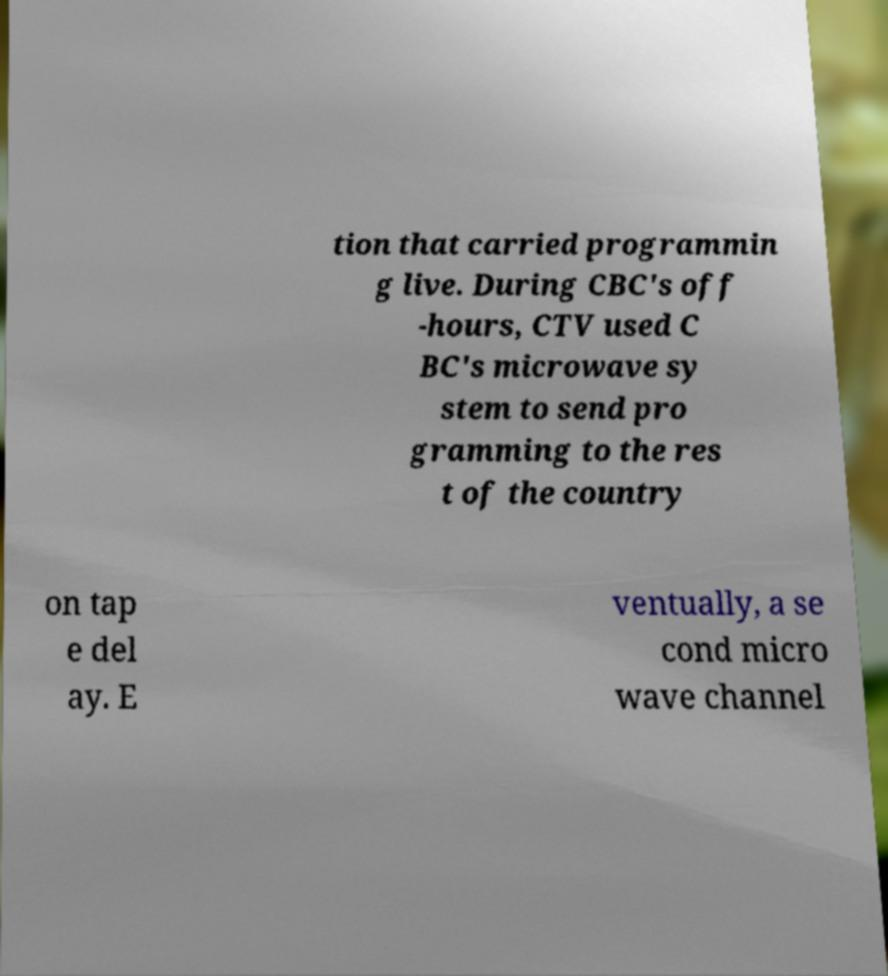What messages or text are displayed in this image? I need them in a readable, typed format. tion that carried programmin g live. During CBC's off -hours, CTV used C BC's microwave sy stem to send pro gramming to the res t of the country on tap e del ay. E ventually, a se cond micro wave channel 